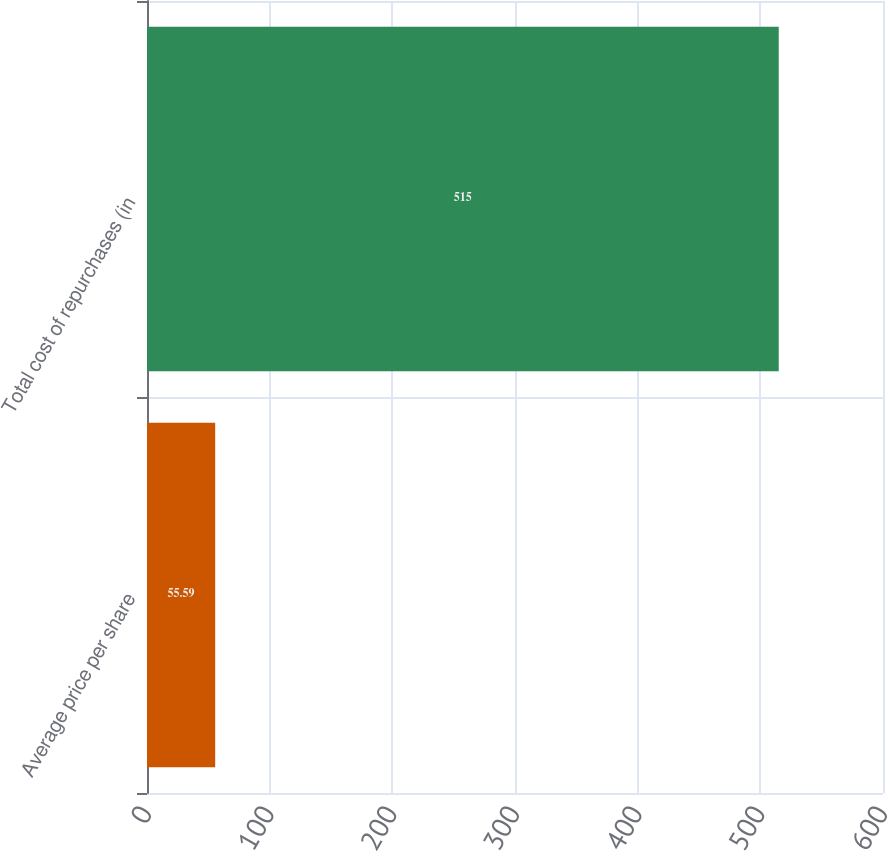<chart> <loc_0><loc_0><loc_500><loc_500><bar_chart><fcel>Average price per share<fcel>Total cost of repurchases (in<nl><fcel>55.59<fcel>515<nl></chart> 